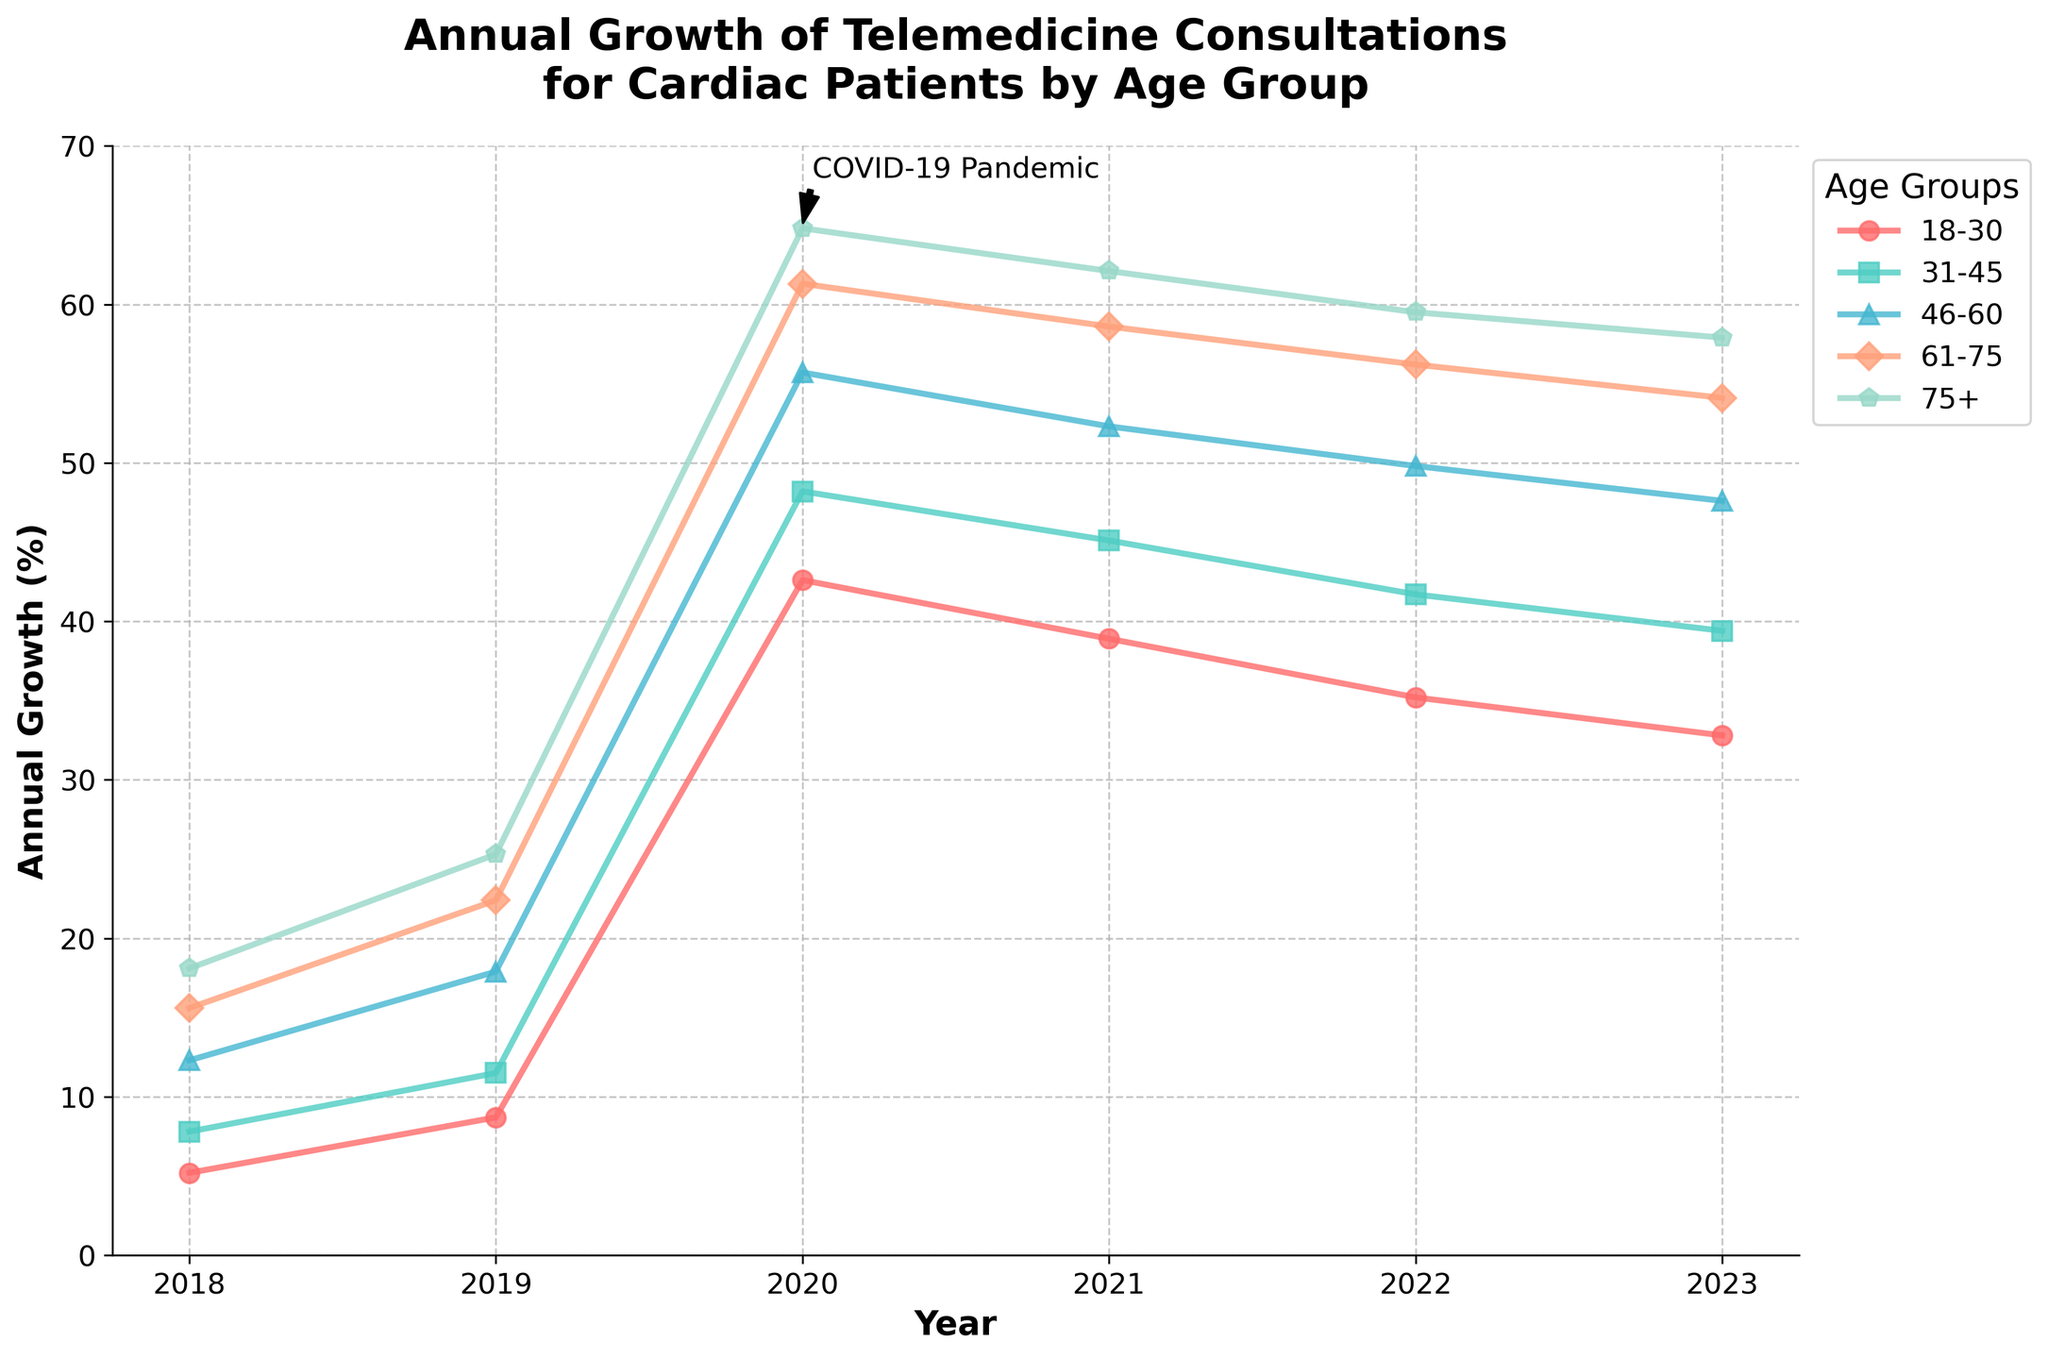Which age group experienced the highest growth in telemedicine consultations during the peak year? By observing the figure, we see that 2020 is the peak year for all age groups. Among them, the 75+ age group reached the highest growth at around 64.8%.
Answer: 75+ Between 2019 and 2020, which age group saw the largest increase in telemedicine consultations? By calculating the difference between the values for 2019 and 2020 for each age group: 18-30: 42.6 - 8.7 = 33.9, 31-45: 48.2 - 11.5 = 36.7, 46-60: 55.7 - 17.9 = 37.8, 61-75: 61.3 - 22.4 = 38.9, 75+: 64.8 - 25.3 = 39.5. The 75+ age group saw the largest increase at 39.5%.
Answer: 75+ Which year marked the start of a decline in telemedicine consultation growth for all age groups? By examining the figure, we see that the growth rates for all age groups were at their peak in 2020 and started declining thereafter from 2021.
Answer: 2021 What's the total annual growth percentage for the 46-60 age group from 2018 to 2023? Determine the total growth by summing the values for the 46-60 age group from 2018 to 2023: 12.3 + 17.9 + 55.7 + 52.3 + 49.8 + 47.6 = 235.6%.
Answer: 235.6% Compare the growth trend for the 18-30 and 31-45 age groups in 2021. Which group had a higher growth rate? In 2021, the figures show that the 18-30 age group had an annual growth of 38.9%, whereas the 31-45 age group had a growth of 45.1%. Comparing these values, the 31-45 age group had a higher growth rate.
Answer: 31-45 What visual indicator is used to highlight the impact of the COVID-19 Pandemic on telemedicine consultations? The figure includes an annotation pointing to the year 2020 marked as "COVID-19 Pandemic" with an arrow.
Answer: Annotation with an arrow Which age group's growth rate showed the most consistent decline from the peak year to 2023? Observing the figure, the 75+ age group shows the most consistent decline from 64.8% in 2020 to 57.9% in 2023, with clear decreases each year.
Answer: 75+ How much did the annual growth rate for the 61-75 age group decline from its peak in 2020 to 2023? Calculate the decline by subtracting the 2023 value from the 2020 value for the 61-75 age group: 61.3 - 54.1 = 7.2%.
Answer: 7.2% What color represents the 31-45 age group in the plot? By looking at the figure, the 31-45 age group is represented by the green-colored line.
Answer: Green 